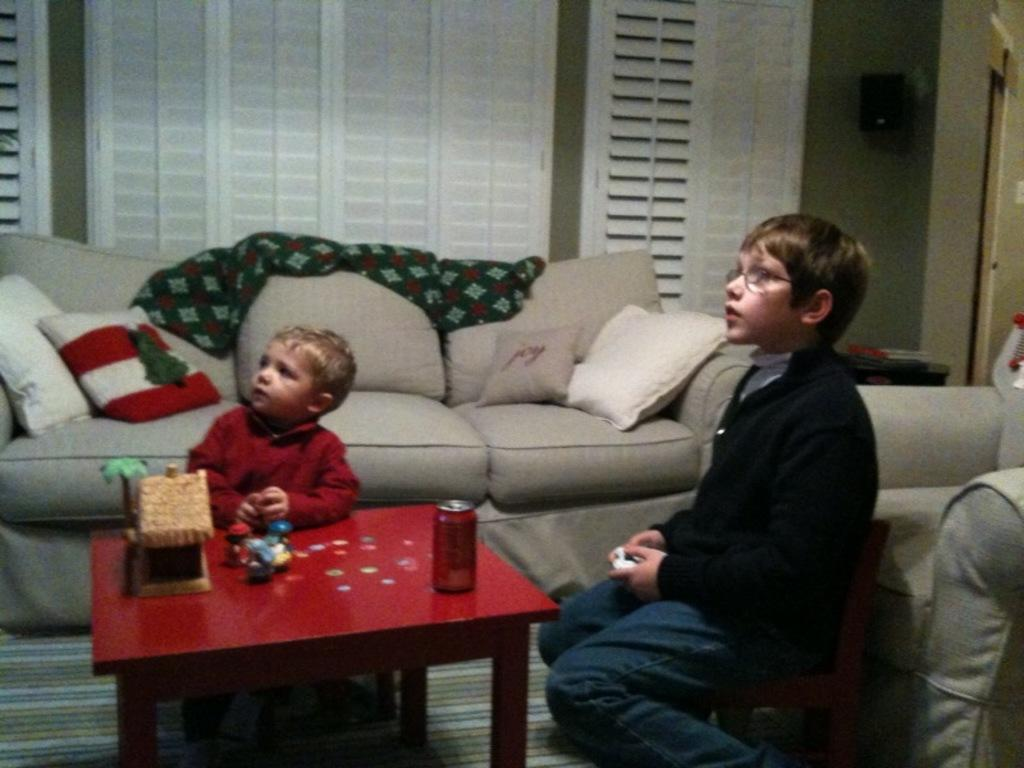How many boys are present in the image? There are two boys in the image. What are the boys doing in the image? The boys are sitting at a table. What direction are the boys looking in the image? The boys are looking aside. What can be seen in the background of the image? There is a sofa in the background of the image. What type of weather can be seen through the window in the image? There is no window present in the image, so it is not possible to determine the weather from the image. 